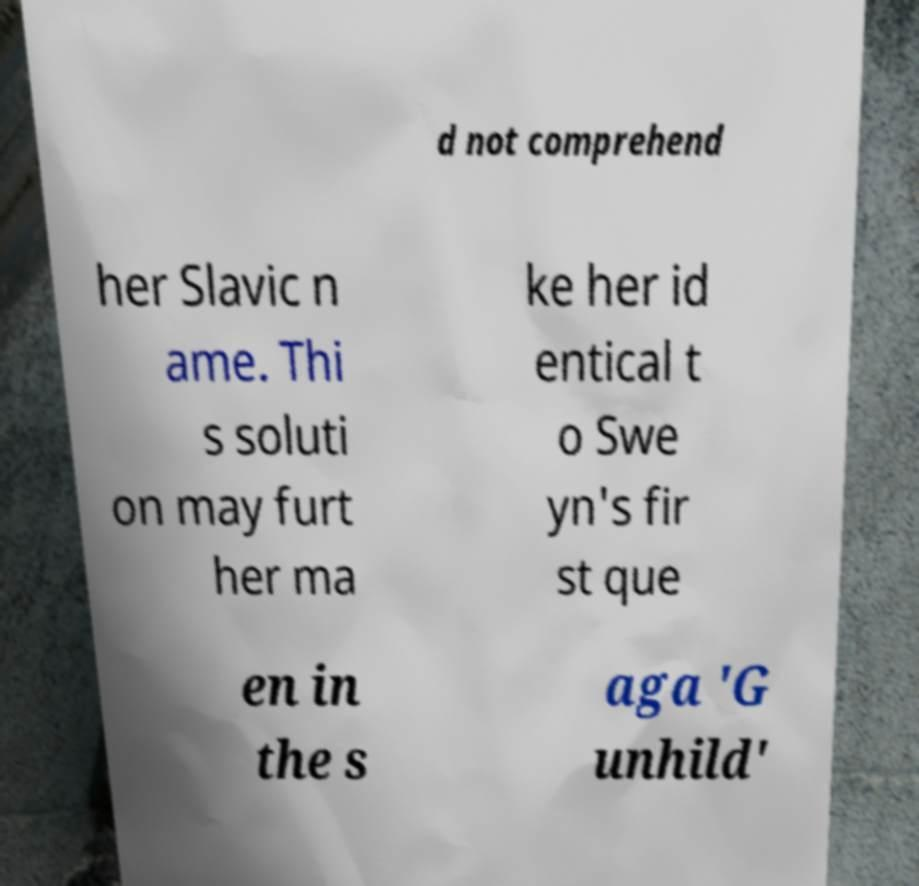Please identify and transcribe the text found in this image. d not comprehend her Slavic n ame. Thi s soluti on may furt her ma ke her id entical t o Swe yn's fir st que en in the s aga 'G unhild' 